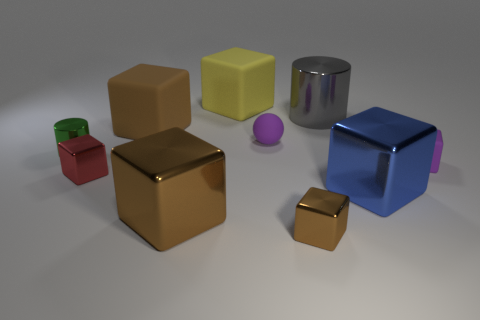How many brown blocks must be subtracted to get 1 brown blocks? 2 Subtract all red balls. How many brown cubes are left? 3 Subtract all red cubes. How many cubes are left? 6 Subtract all tiny blocks. How many blocks are left? 4 Subtract 3 cubes. How many cubes are left? 4 Subtract all brown cubes. Subtract all gray balls. How many cubes are left? 4 Subtract all cylinders. How many objects are left? 8 Subtract all green shiny things. Subtract all small green cylinders. How many objects are left? 8 Add 9 red objects. How many red objects are left? 10 Add 5 large cyan metal blocks. How many large cyan metal blocks exist? 5 